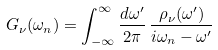Convert formula to latex. <formula><loc_0><loc_0><loc_500><loc_500>G _ { \nu } ( \omega _ { n } ) = \int _ { - \infty } ^ { \infty } \frac { d \omega ^ { \prime } } { 2 \pi } \, \frac { \rho _ { \nu } ( \omega ^ { \prime } ) } { i \omega _ { n } - \omega ^ { \prime } }</formula> 